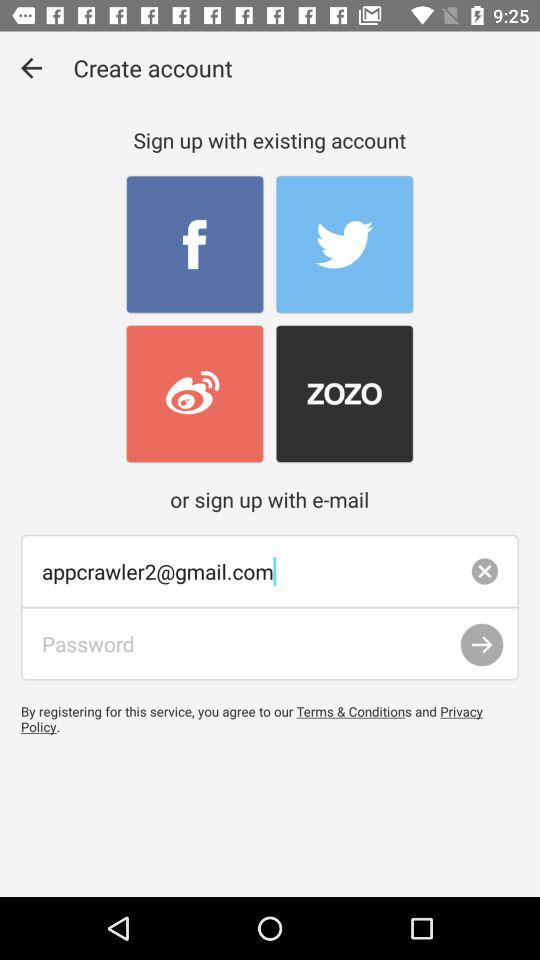Through which applications can we sign up? You can sign up through "Facebook", "Twitter", "Weibo" and "ZOZO". 